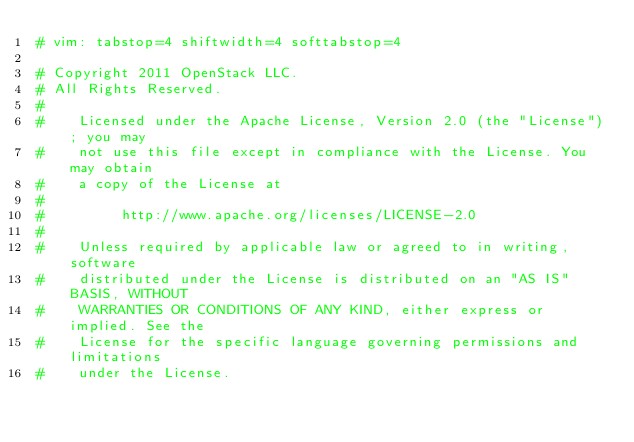Convert code to text. <code><loc_0><loc_0><loc_500><loc_500><_Python_># vim: tabstop=4 shiftwidth=4 softtabstop=4

# Copyright 2011 OpenStack LLC.
# All Rights Reserved.
#
#    Licensed under the Apache License, Version 2.0 (the "License"); you may
#    not use this file except in compliance with the License. You may obtain
#    a copy of the License at
#
#         http://www.apache.org/licenses/LICENSE-2.0
#
#    Unless required by applicable law or agreed to in writing, software
#    distributed under the License is distributed on an "AS IS" BASIS, WITHOUT
#    WARRANTIES OR CONDITIONS OF ANY KIND, either express or implied. See the
#    License for the specific language governing permissions and limitations
#    under the License.
</code> 